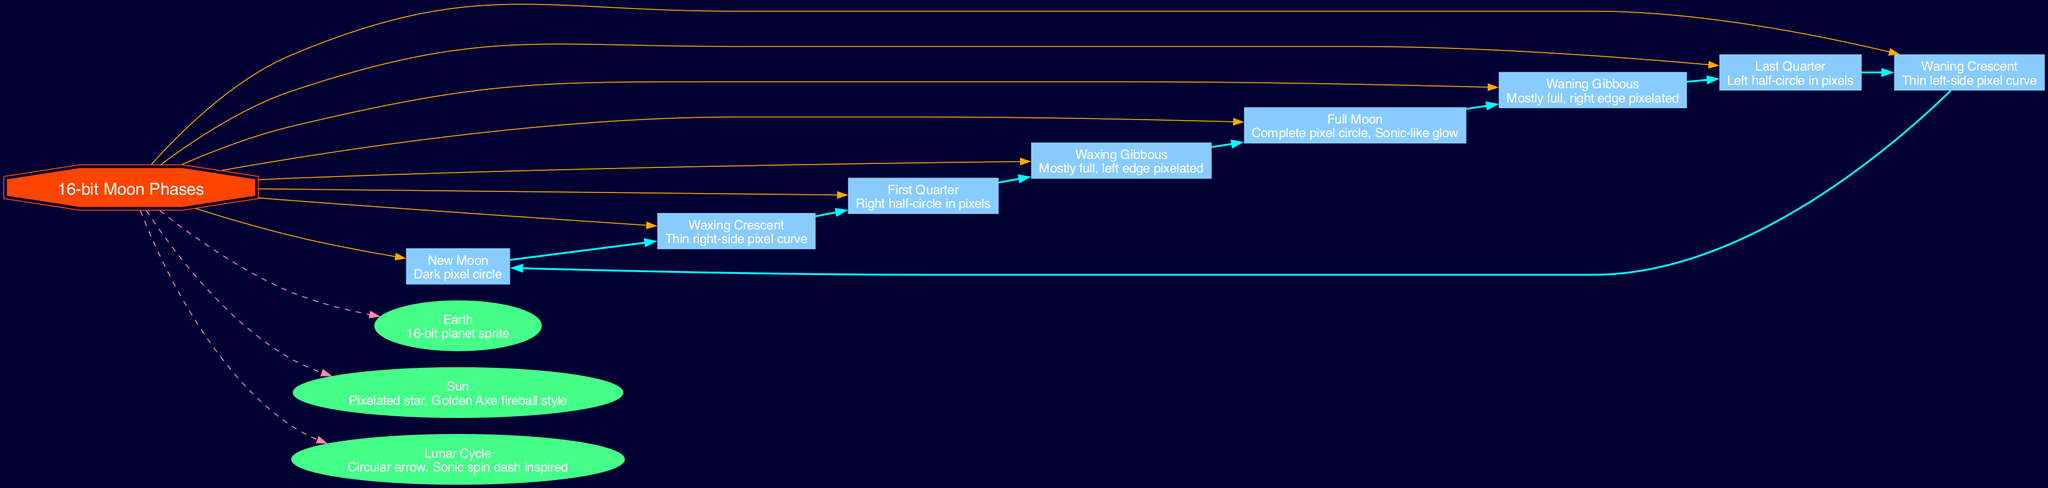What is the first moon phase listed? The first moon phase in the diagram is "New Moon," which can be identified by its position and the description given.
Answer: New Moon How many moon phases are there in total? Counting the phases listed in the diagram, we have eight distinct phases represented, including New Moon and Full Moon.
Answer: 8 What color is the central topic node? The central topic node, labeled "16-bit Moon Phases," is colored #FF4400 as indicated in the diagram attributes.
Answer: #FF4400 Which phase shows a complete pixel circle? The phase that depicts a complete pixel circle is "Full Moon," as described in its entry within the diagram.
Answer: Full Moon Which additional element has a dashed edge connection? The additional elements, specifically Earth and Sun, are connected to the central node with dashed edges, showcasing their relationships clearly.
Answer: Earth, Sun What is the description of the Waxing Gibbous phase? The description for the Waxing Gibbous phase specifies it as "Mostly full, left edge pixelated." This information is directly written in the phase's representation.
Answer: Mostly full, left edge pixelated How many elements are shown in the diagram? The diagram illustrates three additional elements: Earth, Sun, and Lunar Cycle, making the total count of elements three.
Answer: 3 What is the visual style of the Sun in the diagram? The Sun is represented as a "Pixelated star, Golden Axe fireball style," highlighting its unique appearance in the diagram's context.
Answer: Pixelated star, Golden Axe fireball style Which phase follows the Last Quarter phase in the lunar cycle? In the cyclical nature represented in the diagram, the phase following Last Quarter is the Waning Crescent, as shown by the connecting edges.
Answer: Waning Crescent 